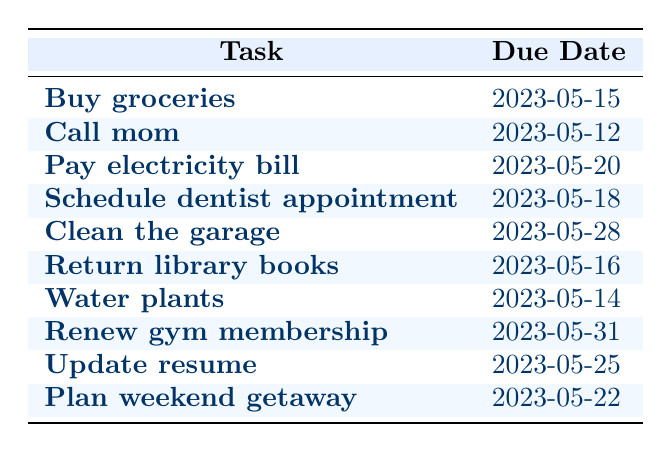What is the due date for "Call mom"? The task "Call mom" is listed in the table, and its due date is provided right next to it. Referring to the table, the due date for "Call mom" is 2023-05-12.
Answer: 2023-05-12 How many tasks are due before May 20, 2023? To find the number of tasks due before May 20, I will look at the due dates of each task. The tasks due before that date are "Call mom" (2023-05-12), "Water plants" (2023-05-14), "Buy groceries" (2023-05-15), and "Return library books" (2023-05-16). There are four tasks in total.
Answer: 4 Is "Pay electricity bill" due after "Return library books"? I will compare the due dates of both tasks. "Pay electricity bill" is due on 2023-05-20, while "Return library books" is due on 2023-05-16. Since 2023-05-20 is later than 2023-05-16, the statement is true.
Answer: Yes What is the task due closest to May 20, 2023? I will examine the due dates and find the ones closest to May 20, starting from the earliest date. The tasks just before May 20 are "Return library books" (2023-05-16), followed by "Schedule dentist appointment" (2023-05-18), and then "Pay electricity bill" (2023-05-20). The task closest to May 20 is "Pay electricity bill".
Answer: Pay electricity bill Which tasks are due on an even-numbered date? I will list out all the due dates and check which are even. The tasks with due dates are as follows: "Call mom" (12), "Buy groceries" (15), "Pay electricity bill" (20), "Schedule dentist appointment" (18), "Return library books" (16), "Water plants" (14), "Renew gym membership" (31), "Update resume" (25), and "Plan weekend getaway" (22). The even-numbered due dates are 12, 14, 16, 18, 20, and 22. The corresponding tasks are "Call mom", "Water plants", "Return library books", "Schedule dentist appointment", "Pay electricity bill", and "Plan weekend getaway".
Answer: Call mom, Water plants, Return library books, Schedule dentist appointment, Pay electricity bill, Plan weekend getaway 